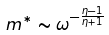Convert formula to latex. <formula><loc_0><loc_0><loc_500><loc_500>m ^ { * } \sim \omega ^ { - \frac { \eta - 1 } { \eta + 1 } }</formula> 